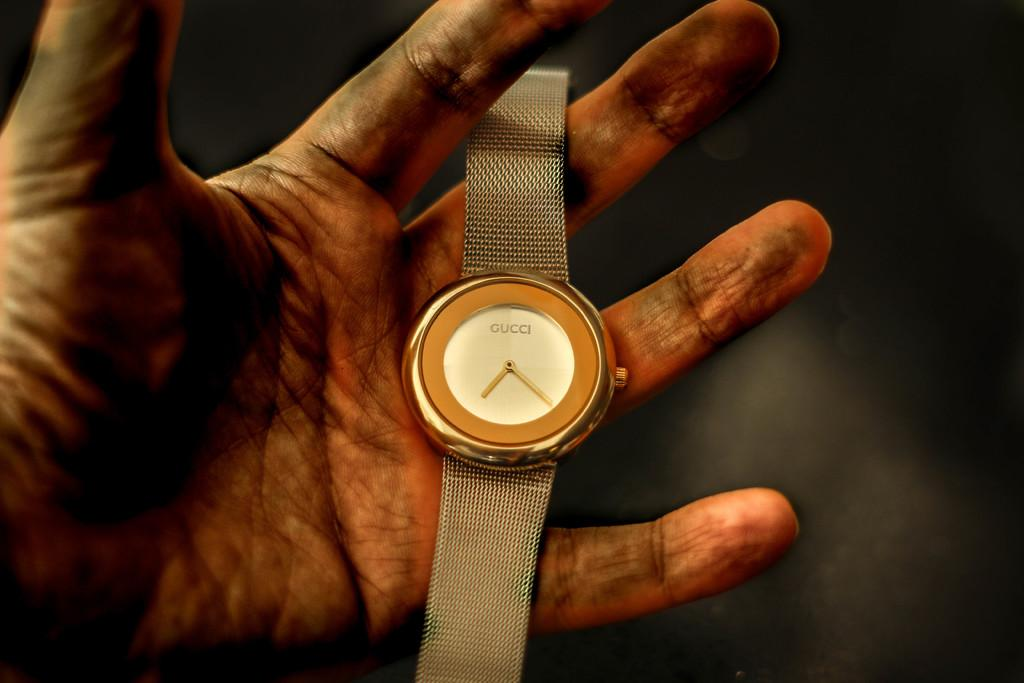<image>
Give a short and clear explanation of the subsequent image. A gold Gucci watch in a dirty hand 